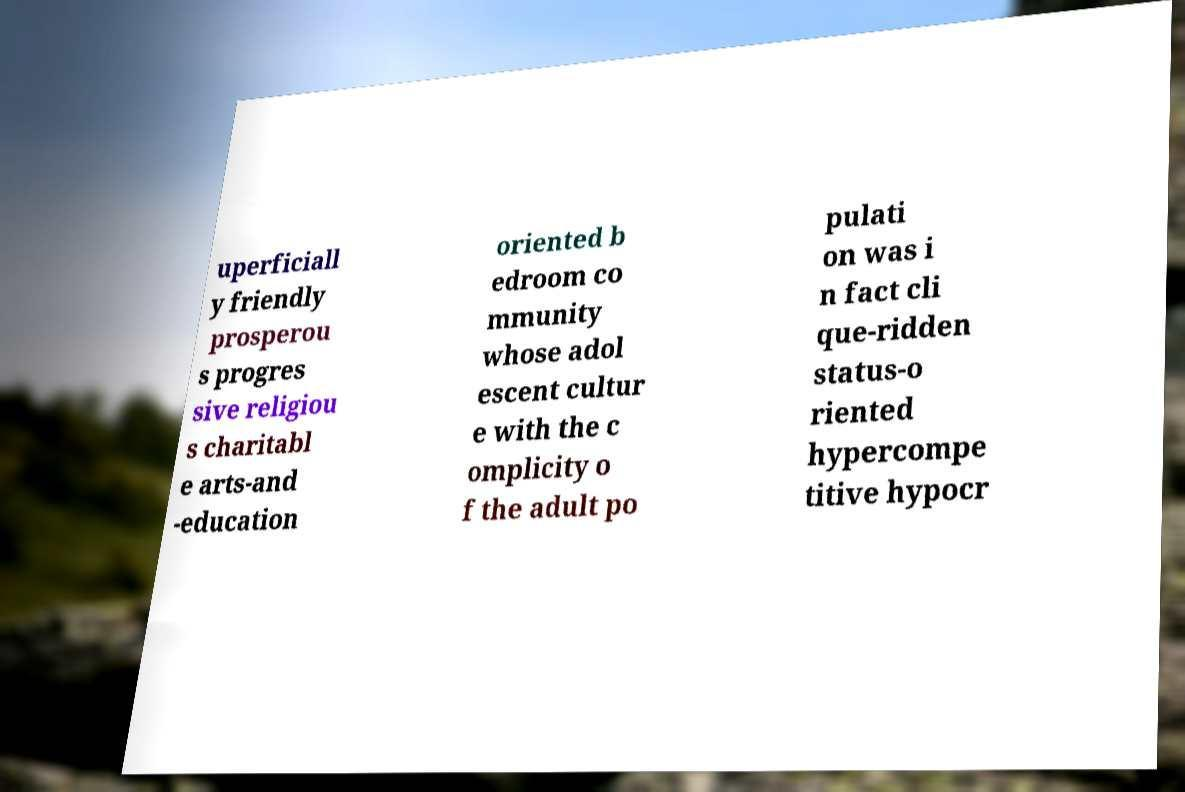For documentation purposes, I need the text within this image transcribed. Could you provide that? uperficiall y friendly prosperou s progres sive religiou s charitabl e arts-and -education oriented b edroom co mmunity whose adol escent cultur e with the c omplicity o f the adult po pulati on was i n fact cli que-ridden status-o riented hypercompe titive hypocr 